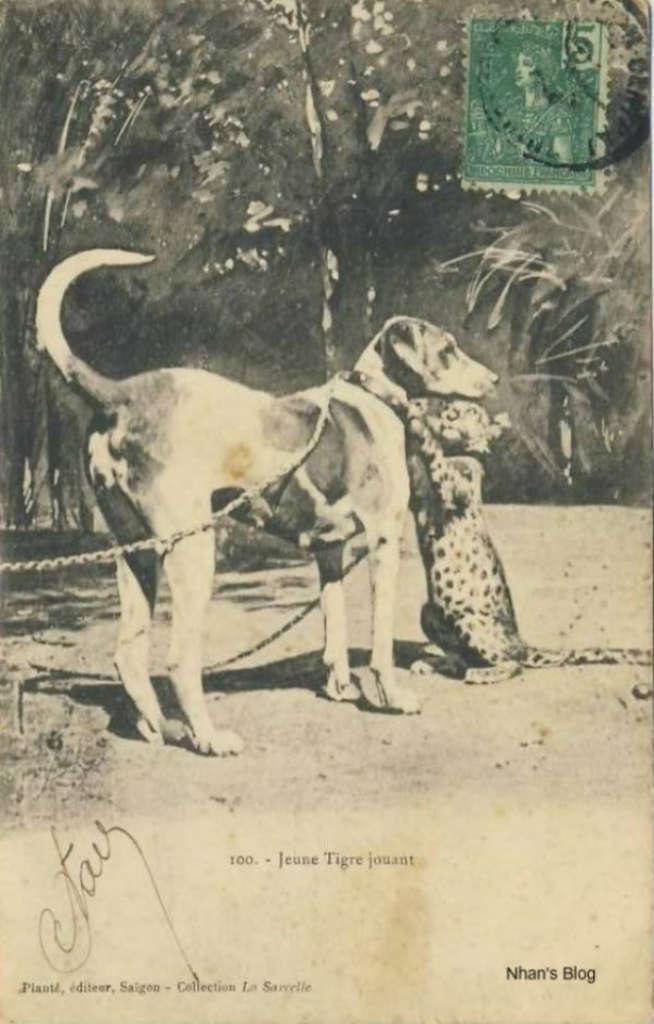Please provide a concise description of this image. This is a black and white picture. In this picture, we see two dogs. At the bottom of the picture, we see some text written. In the background there are trees and a wall. In the right top of the picture, we see a revenue stamp in green color. 